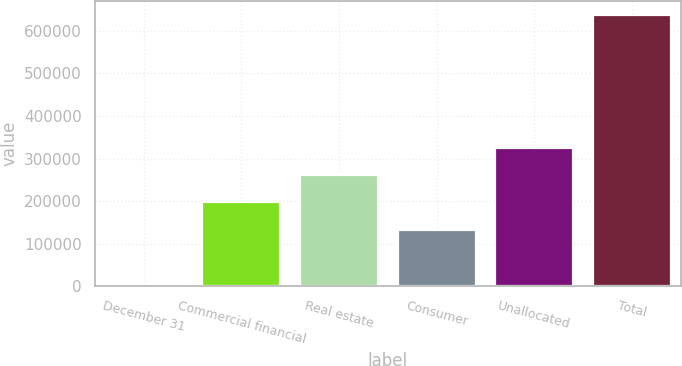Convert chart. <chart><loc_0><loc_0><loc_500><loc_500><bar_chart><fcel>December 31<fcel>Commercial financial<fcel>Real estate<fcel>Consumer<fcel>Unallocated<fcel>Total<nl><fcel>2005<fcel>197107<fcel>260673<fcel>133541<fcel>324238<fcel>637663<nl></chart> 